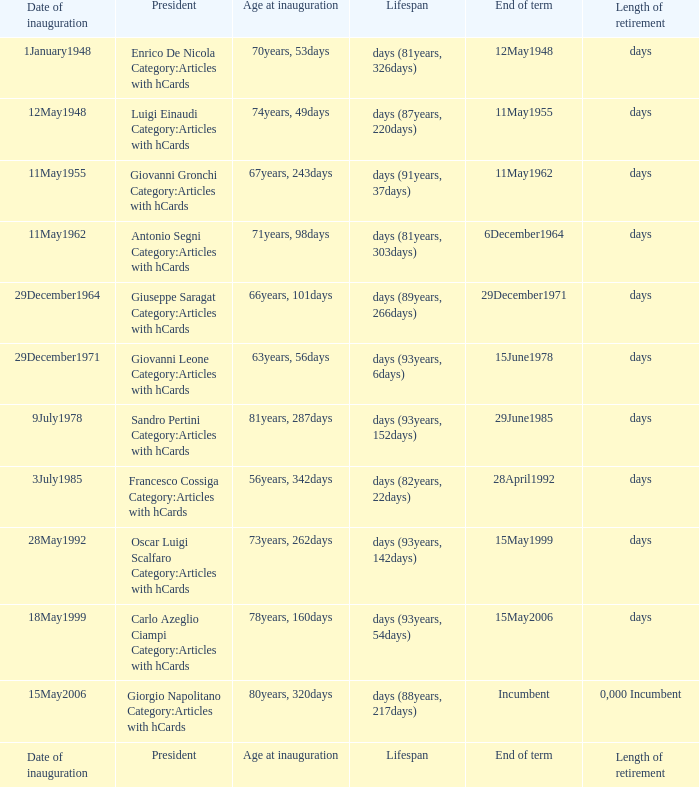What is the Length of retirement of the President with an Age at inauguration of 70years, 53days? Days. 